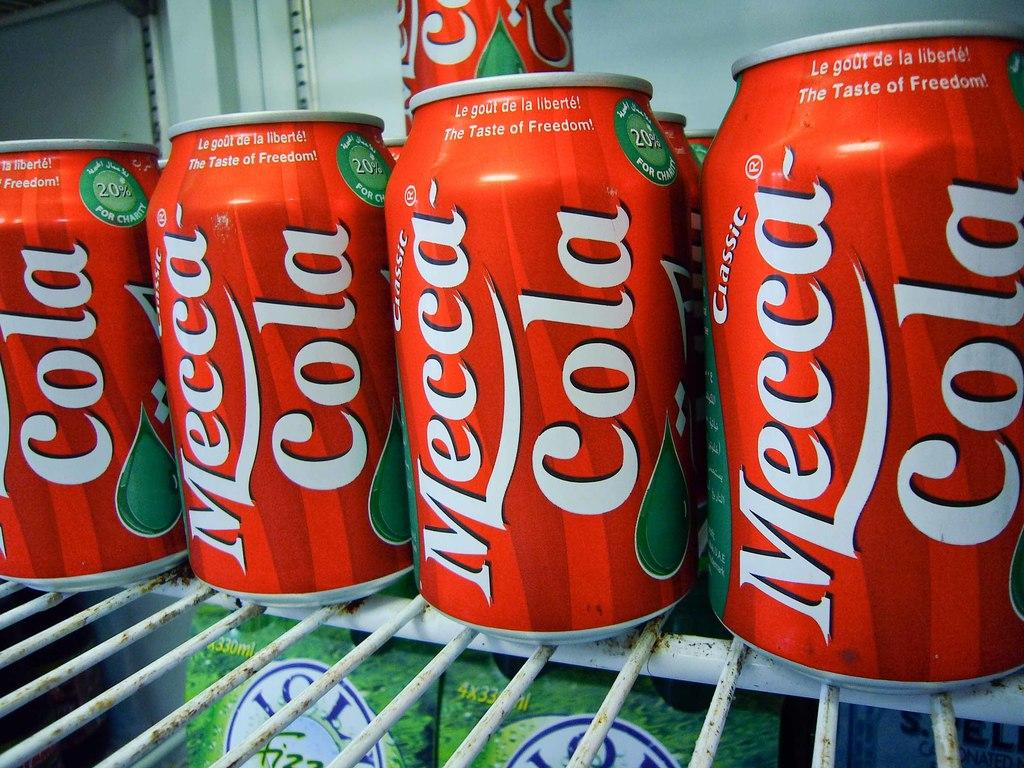<image>
Provide a brief description of the given image. Soda cans of Mecca Cola are on a wire rack. 